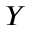<formula> <loc_0><loc_0><loc_500><loc_500>Y</formula> 